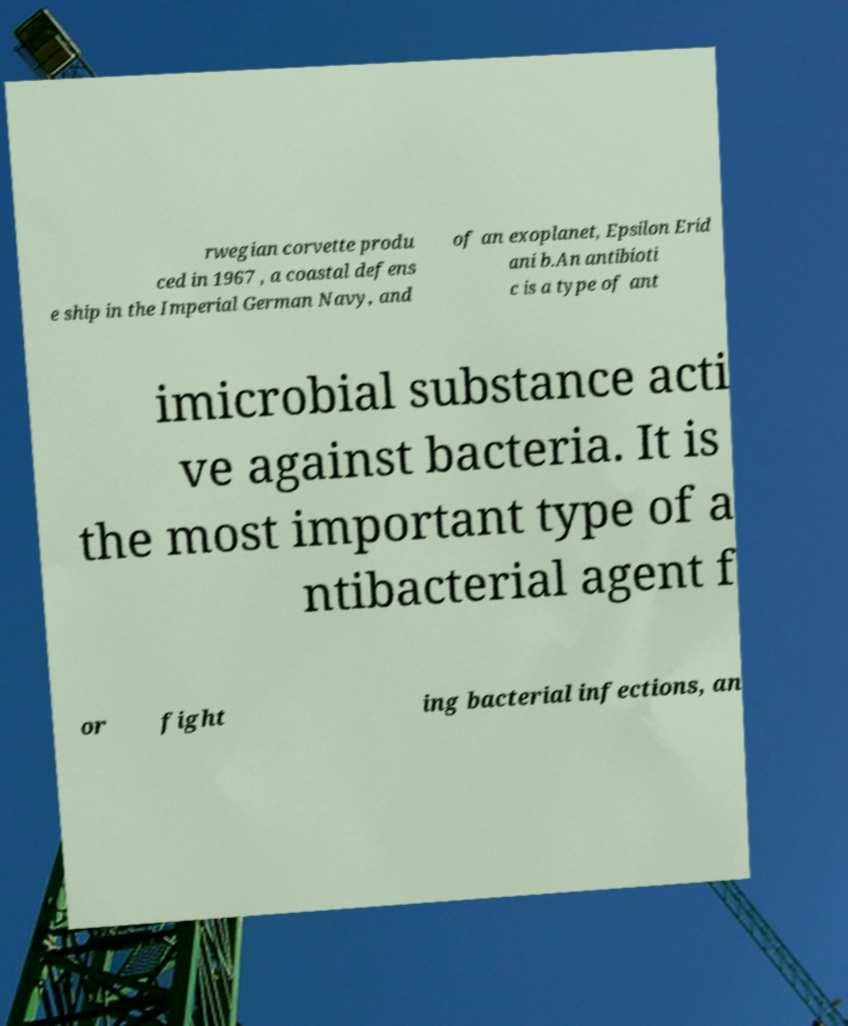There's text embedded in this image that I need extracted. Can you transcribe it verbatim? rwegian corvette produ ced in 1967 , a coastal defens e ship in the Imperial German Navy, and of an exoplanet, Epsilon Erid ani b.An antibioti c is a type of ant imicrobial substance acti ve against bacteria. It is the most important type of a ntibacterial agent f or fight ing bacterial infections, an 